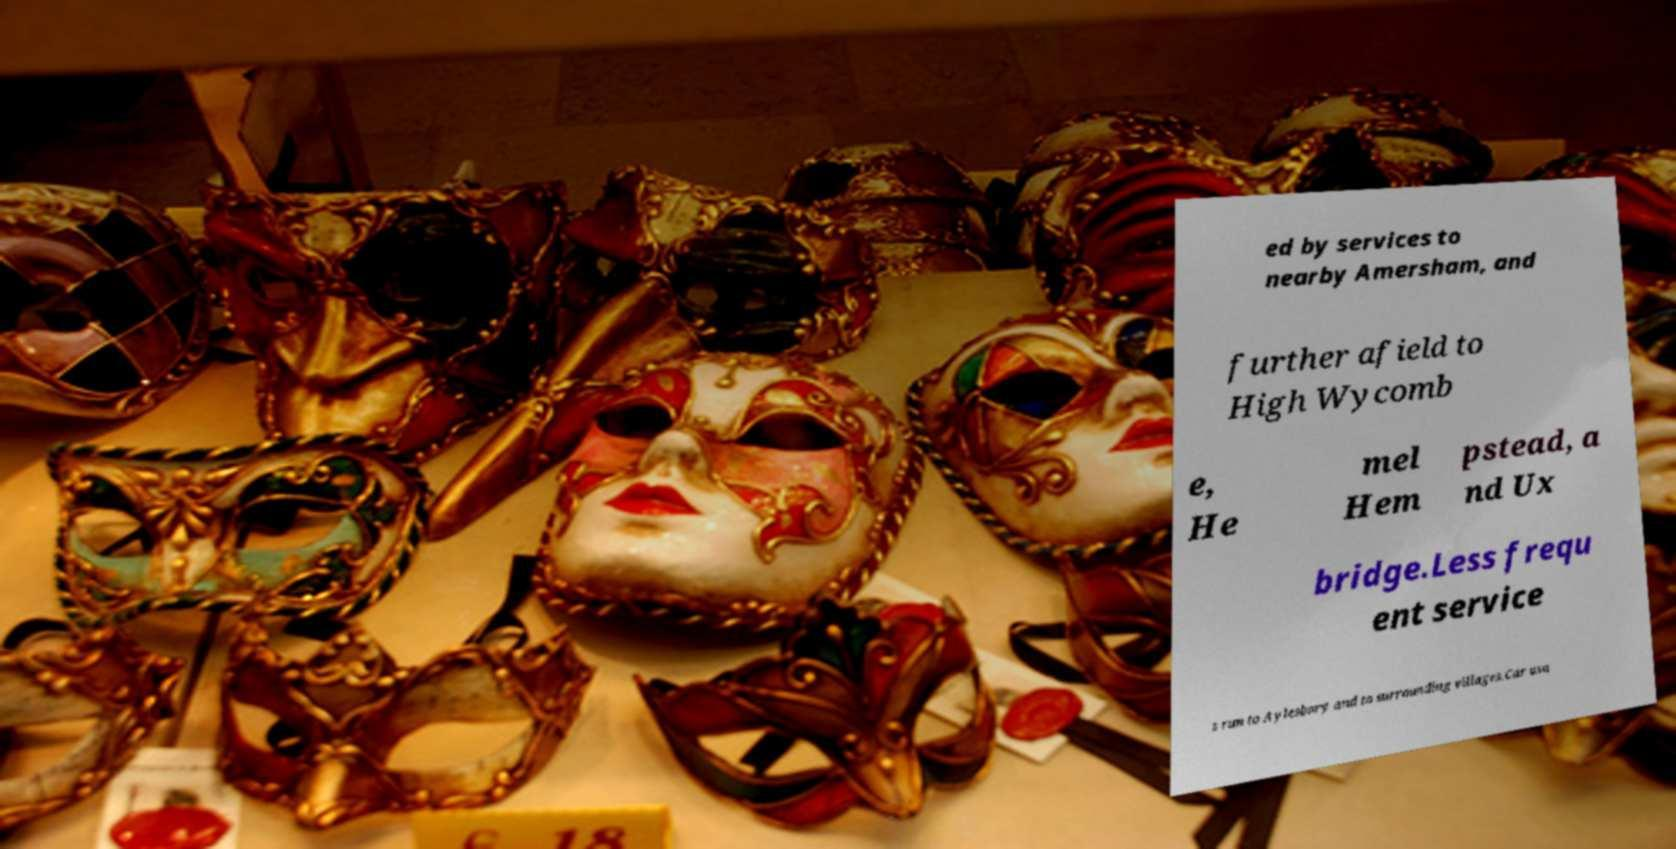Please identify and transcribe the text found in this image. ed by services to nearby Amersham, and further afield to High Wycomb e, He mel Hem pstead, a nd Ux bridge.Less frequ ent service s run to Aylesbury and to surrounding villages.Car usa 